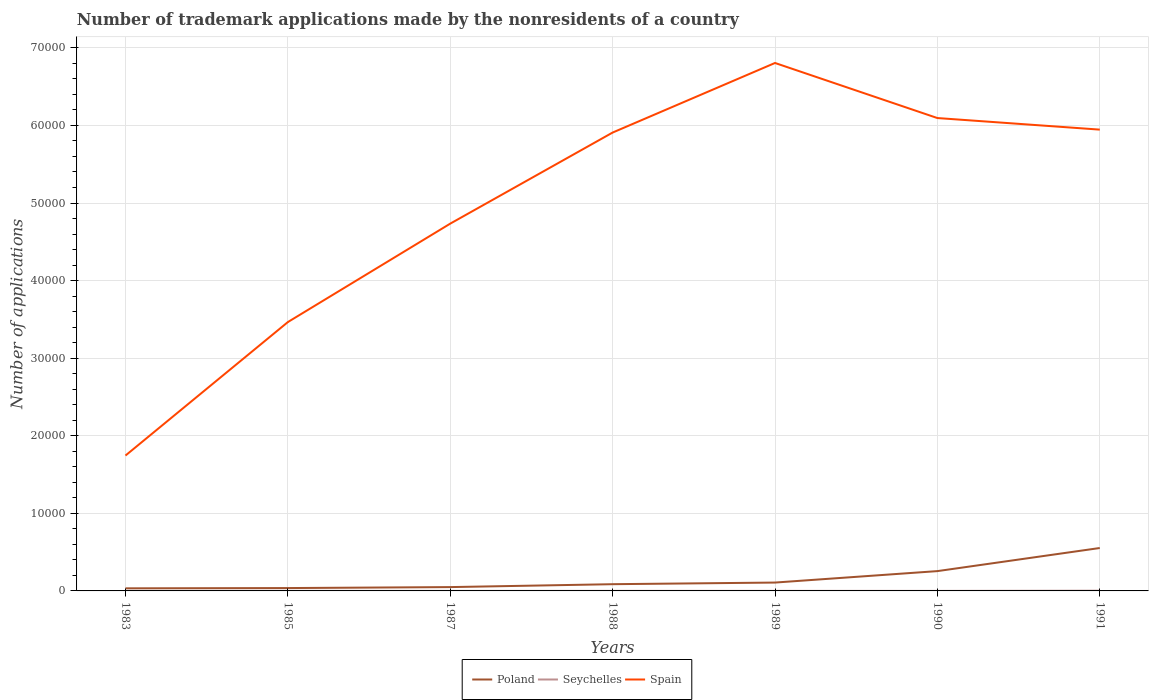How many different coloured lines are there?
Your answer should be compact. 3. In which year was the number of trademark applications made by the nonresidents in Poland maximum?
Provide a short and direct response. 1983. What is the difference between two consecutive major ticks on the Y-axis?
Your answer should be very brief. 10000. Where does the legend appear in the graph?
Make the answer very short. Bottom center. What is the title of the graph?
Ensure brevity in your answer.  Number of trademark applications made by the nonresidents of a country. Does "Somalia" appear as one of the legend labels in the graph?
Provide a succinct answer. No. What is the label or title of the X-axis?
Your answer should be very brief. Years. What is the label or title of the Y-axis?
Keep it short and to the point. Number of applications. What is the Number of applications in Poland in 1983?
Provide a succinct answer. 334. What is the Number of applications of Spain in 1983?
Provide a short and direct response. 1.74e+04. What is the Number of applications in Poland in 1985?
Offer a terse response. 369. What is the Number of applications in Spain in 1985?
Offer a terse response. 3.47e+04. What is the Number of applications of Poland in 1987?
Provide a short and direct response. 494. What is the Number of applications in Seychelles in 1987?
Give a very brief answer. 3. What is the Number of applications in Spain in 1987?
Keep it short and to the point. 4.73e+04. What is the Number of applications of Poland in 1988?
Provide a succinct answer. 867. What is the Number of applications of Spain in 1988?
Your answer should be very brief. 5.91e+04. What is the Number of applications of Poland in 1989?
Give a very brief answer. 1077. What is the Number of applications in Seychelles in 1989?
Offer a terse response. 7. What is the Number of applications of Spain in 1989?
Provide a short and direct response. 6.81e+04. What is the Number of applications of Poland in 1990?
Make the answer very short. 2554. What is the Number of applications of Seychelles in 1990?
Ensure brevity in your answer.  3. What is the Number of applications in Spain in 1990?
Your response must be concise. 6.10e+04. What is the Number of applications in Poland in 1991?
Your answer should be compact. 5531. What is the Number of applications in Seychelles in 1991?
Make the answer very short. 31. What is the Number of applications in Spain in 1991?
Ensure brevity in your answer.  5.95e+04. Across all years, what is the maximum Number of applications in Poland?
Your answer should be very brief. 5531. Across all years, what is the maximum Number of applications in Spain?
Give a very brief answer. 6.81e+04. Across all years, what is the minimum Number of applications in Poland?
Make the answer very short. 334. Across all years, what is the minimum Number of applications of Seychelles?
Your answer should be compact. 3. Across all years, what is the minimum Number of applications in Spain?
Keep it short and to the point. 1.74e+04. What is the total Number of applications of Poland in the graph?
Offer a terse response. 1.12e+04. What is the total Number of applications of Seychelles in the graph?
Provide a succinct answer. 67. What is the total Number of applications in Spain in the graph?
Provide a succinct answer. 3.47e+05. What is the difference between the Number of applications in Poland in 1983 and that in 1985?
Make the answer very short. -35. What is the difference between the Number of applications in Seychelles in 1983 and that in 1985?
Your response must be concise. -8. What is the difference between the Number of applications in Spain in 1983 and that in 1985?
Provide a succinct answer. -1.72e+04. What is the difference between the Number of applications of Poland in 1983 and that in 1987?
Your answer should be compact. -160. What is the difference between the Number of applications of Spain in 1983 and that in 1987?
Your answer should be very brief. -2.99e+04. What is the difference between the Number of applications of Poland in 1983 and that in 1988?
Offer a terse response. -533. What is the difference between the Number of applications of Spain in 1983 and that in 1988?
Provide a short and direct response. -4.16e+04. What is the difference between the Number of applications in Poland in 1983 and that in 1989?
Provide a succinct answer. -743. What is the difference between the Number of applications in Spain in 1983 and that in 1989?
Make the answer very short. -5.06e+04. What is the difference between the Number of applications of Poland in 1983 and that in 1990?
Offer a very short reply. -2220. What is the difference between the Number of applications of Seychelles in 1983 and that in 1990?
Your answer should be compact. 1. What is the difference between the Number of applications of Spain in 1983 and that in 1990?
Provide a short and direct response. -4.35e+04. What is the difference between the Number of applications in Poland in 1983 and that in 1991?
Your answer should be very brief. -5197. What is the difference between the Number of applications of Spain in 1983 and that in 1991?
Keep it short and to the point. -4.20e+04. What is the difference between the Number of applications of Poland in 1985 and that in 1987?
Provide a short and direct response. -125. What is the difference between the Number of applications of Spain in 1985 and that in 1987?
Your response must be concise. -1.27e+04. What is the difference between the Number of applications of Poland in 1985 and that in 1988?
Offer a terse response. -498. What is the difference between the Number of applications in Spain in 1985 and that in 1988?
Your response must be concise. -2.44e+04. What is the difference between the Number of applications of Poland in 1985 and that in 1989?
Give a very brief answer. -708. What is the difference between the Number of applications of Seychelles in 1985 and that in 1989?
Provide a short and direct response. 5. What is the difference between the Number of applications in Spain in 1985 and that in 1989?
Your answer should be compact. -3.34e+04. What is the difference between the Number of applications of Poland in 1985 and that in 1990?
Give a very brief answer. -2185. What is the difference between the Number of applications in Spain in 1985 and that in 1990?
Offer a very short reply. -2.63e+04. What is the difference between the Number of applications in Poland in 1985 and that in 1991?
Provide a short and direct response. -5162. What is the difference between the Number of applications in Seychelles in 1985 and that in 1991?
Keep it short and to the point. -19. What is the difference between the Number of applications of Spain in 1985 and that in 1991?
Offer a very short reply. -2.48e+04. What is the difference between the Number of applications in Poland in 1987 and that in 1988?
Give a very brief answer. -373. What is the difference between the Number of applications in Seychelles in 1987 and that in 1988?
Provide a short and direct response. -4. What is the difference between the Number of applications in Spain in 1987 and that in 1988?
Your answer should be very brief. -1.17e+04. What is the difference between the Number of applications of Poland in 1987 and that in 1989?
Make the answer very short. -583. What is the difference between the Number of applications of Seychelles in 1987 and that in 1989?
Give a very brief answer. -4. What is the difference between the Number of applications in Spain in 1987 and that in 1989?
Your answer should be compact. -2.07e+04. What is the difference between the Number of applications of Poland in 1987 and that in 1990?
Keep it short and to the point. -2060. What is the difference between the Number of applications of Seychelles in 1987 and that in 1990?
Make the answer very short. 0. What is the difference between the Number of applications in Spain in 1987 and that in 1990?
Provide a succinct answer. -1.36e+04. What is the difference between the Number of applications of Poland in 1987 and that in 1991?
Your answer should be compact. -5037. What is the difference between the Number of applications of Seychelles in 1987 and that in 1991?
Provide a short and direct response. -28. What is the difference between the Number of applications of Spain in 1987 and that in 1991?
Your response must be concise. -1.21e+04. What is the difference between the Number of applications in Poland in 1988 and that in 1989?
Keep it short and to the point. -210. What is the difference between the Number of applications of Seychelles in 1988 and that in 1989?
Keep it short and to the point. 0. What is the difference between the Number of applications in Spain in 1988 and that in 1989?
Give a very brief answer. -8969. What is the difference between the Number of applications in Poland in 1988 and that in 1990?
Offer a very short reply. -1687. What is the difference between the Number of applications in Seychelles in 1988 and that in 1990?
Your answer should be compact. 4. What is the difference between the Number of applications in Spain in 1988 and that in 1990?
Offer a very short reply. -1869. What is the difference between the Number of applications of Poland in 1988 and that in 1991?
Your answer should be very brief. -4664. What is the difference between the Number of applications of Seychelles in 1988 and that in 1991?
Provide a short and direct response. -24. What is the difference between the Number of applications in Spain in 1988 and that in 1991?
Your answer should be compact. -377. What is the difference between the Number of applications of Poland in 1989 and that in 1990?
Offer a very short reply. -1477. What is the difference between the Number of applications in Spain in 1989 and that in 1990?
Give a very brief answer. 7100. What is the difference between the Number of applications of Poland in 1989 and that in 1991?
Offer a very short reply. -4454. What is the difference between the Number of applications in Spain in 1989 and that in 1991?
Your answer should be very brief. 8592. What is the difference between the Number of applications of Poland in 1990 and that in 1991?
Offer a terse response. -2977. What is the difference between the Number of applications of Spain in 1990 and that in 1991?
Provide a short and direct response. 1492. What is the difference between the Number of applications of Poland in 1983 and the Number of applications of Seychelles in 1985?
Your answer should be compact. 322. What is the difference between the Number of applications of Poland in 1983 and the Number of applications of Spain in 1985?
Ensure brevity in your answer.  -3.43e+04. What is the difference between the Number of applications in Seychelles in 1983 and the Number of applications in Spain in 1985?
Your response must be concise. -3.47e+04. What is the difference between the Number of applications of Poland in 1983 and the Number of applications of Seychelles in 1987?
Your response must be concise. 331. What is the difference between the Number of applications of Poland in 1983 and the Number of applications of Spain in 1987?
Your answer should be very brief. -4.70e+04. What is the difference between the Number of applications of Seychelles in 1983 and the Number of applications of Spain in 1987?
Your answer should be compact. -4.73e+04. What is the difference between the Number of applications in Poland in 1983 and the Number of applications in Seychelles in 1988?
Provide a short and direct response. 327. What is the difference between the Number of applications of Poland in 1983 and the Number of applications of Spain in 1988?
Offer a very short reply. -5.88e+04. What is the difference between the Number of applications of Seychelles in 1983 and the Number of applications of Spain in 1988?
Your response must be concise. -5.91e+04. What is the difference between the Number of applications of Poland in 1983 and the Number of applications of Seychelles in 1989?
Provide a succinct answer. 327. What is the difference between the Number of applications of Poland in 1983 and the Number of applications of Spain in 1989?
Offer a terse response. -6.77e+04. What is the difference between the Number of applications in Seychelles in 1983 and the Number of applications in Spain in 1989?
Your answer should be compact. -6.80e+04. What is the difference between the Number of applications in Poland in 1983 and the Number of applications in Seychelles in 1990?
Give a very brief answer. 331. What is the difference between the Number of applications in Poland in 1983 and the Number of applications in Spain in 1990?
Give a very brief answer. -6.06e+04. What is the difference between the Number of applications in Seychelles in 1983 and the Number of applications in Spain in 1990?
Your answer should be compact. -6.10e+04. What is the difference between the Number of applications of Poland in 1983 and the Number of applications of Seychelles in 1991?
Offer a very short reply. 303. What is the difference between the Number of applications in Poland in 1983 and the Number of applications in Spain in 1991?
Provide a succinct answer. -5.91e+04. What is the difference between the Number of applications in Seychelles in 1983 and the Number of applications in Spain in 1991?
Give a very brief answer. -5.95e+04. What is the difference between the Number of applications in Poland in 1985 and the Number of applications in Seychelles in 1987?
Offer a terse response. 366. What is the difference between the Number of applications of Poland in 1985 and the Number of applications of Spain in 1987?
Provide a succinct answer. -4.70e+04. What is the difference between the Number of applications in Seychelles in 1985 and the Number of applications in Spain in 1987?
Your answer should be very brief. -4.73e+04. What is the difference between the Number of applications in Poland in 1985 and the Number of applications in Seychelles in 1988?
Your answer should be compact. 362. What is the difference between the Number of applications in Poland in 1985 and the Number of applications in Spain in 1988?
Make the answer very short. -5.87e+04. What is the difference between the Number of applications of Seychelles in 1985 and the Number of applications of Spain in 1988?
Make the answer very short. -5.91e+04. What is the difference between the Number of applications of Poland in 1985 and the Number of applications of Seychelles in 1989?
Provide a succinct answer. 362. What is the difference between the Number of applications in Poland in 1985 and the Number of applications in Spain in 1989?
Make the answer very short. -6.77e+04. What is the difference between the Number of applications of Seychelles in 1985 and the Number of applications of Spain in 1989?
Your answer should be very brief. -6.80e+04. What is the difference between the Number of applications of Poland in 1985 and the Number of applications of Seychelles in 1990?
Ensure brevity in your answer.  366. What is the difference between the Number of applications in Poland in 1985 and the Number of applications in Spain in 1990?
Provide a short and direct response. -6.06e+04. What is the difference between the Number of applications in Seychelles in 1985 and the Number of applications in Spain in 1990?
Offer a very short reply. -6.09e+04. What is the difference between the Number of applications in Poland in 1985 and the Number of applications in Seychelles in 1991?
Keep it short and to the point. 338. What is the difference between the Number of applications in Poland in 1985 and the Number of applications in Spain in 1991?
Ensure brevity in your answer.  -5.91e+04. What is the difference between the Number of applications in Seychelles in 1985 and the Number of applications in Spain in 1991?
Your response must be concise. -5.94e+04. What is the difference between the Number of applications in Poland in 1987 and the Number of applications in Seychelles in 1988?
Provide a succinct answer. 487. What is the difference between the Number of applications of Poland in 1987 and the Number of applications of Spain in 1988?
Provide a short and direct response. -5.86e+04. What is the difference between the Number of applications of Seychelles in 1987 and the Number of applications of Spain in 1988?
Your answer should be compact. -5.91e+04. What is the difference between the Number of applications of Poland in 1987 and the Number of applications of Seychelles in 1989?
Your answer should be compact. 487. What is the difference between the Number of applications in Poland in 1987 and the Number of applications in Spain in 1989?
Provide a short and direct response. -6.76e+04. What is the difference between the Number of applications of Seychelles in 1987 and the Number of applications of Spain in 1989?
Provide a short and direct response. -6.81e+04. What is the difference between the Number of applications in Poland in 1987 and the Number of applications in Seychelles in 1990?
Give a very brief answer. 491. What is the difference between the Number of applications in Poland in 1987 and the Number of applications in Spain in 1990?
Offer a very short reply. -6.05e+04. What is the difference between the Number of applications in Seychelles in 1987 and the Number of applications in Spain in 1990?
Provide a succinct answer. -6.10e+04. What is the difference between the Number of applications in Poland in 1987 and the Number of applications in Seychelles in 1991?
Offer a terse response. 463. What is the difference between the Number of applications of Poland in 1987 and the Number of applications of Spain in 1991?
Offer a very short reply. -5.90e+04. What is the difference between the Number of applications in Seychelles in 1987 and the Number of applications in Spain in 1991?
Your response must be concise. -5.95e+04. What is the difference between the Number of applications in Poland in 1988 and the Number of applications in Seychelles in 1989?
Offer a terse response. 860. What is the difference between the Number of applications in Poland in 1988 and the Number of applications in Spain in 1989?
Give a very brief answer. -6.72e+04. What is the difference between the Number of applications in Seychelles in 1988 and the Number of applications in Spain in 1989?
Keep it short and to the point. -6.80e+04. What is the difference between the Number of applications in Poland in 1988 and the Number of applications in Seychelles in 1990?
Make the answer very short. 864. What is the difference between the Number of applications in Poland in 1988 and the Number of applications in Spain in 1990?
Your answer should be very brief. -6.01e+04. What is the difference between the Number of applications in Seychelles in 1988 and the Number of applications in Spain in 1990?
Your answer should be compact. -6.09e+04. What is the difference between the Number of applications of Poland in 1988 and the Number of applications of Seychelles in 1991?
Your answer should be very brief. 836. What is the difference between the Number of applications of Poland in 1988 and the Number of applications of Spain in 1991?
Provide a succinct answer. -5.86e+04. What is the difference between the Number of applications in Seychelles in 1988 and the Number of applications in Spain in 1991?
Keep it short and to the point. -5.95e+04. What is the difference between the Number of applications in Poland in 1989 and the Number of applications in Seychelles in 1990?
Offer a terse response. 1074. What is the difference between the Number of applications in Poland in 1989 and the Number of applications in Spain in 1990?
Ensure brevity in your answer.  -5.99e+04. What is the difference between the Number of applications in Seychelles in 1989 and the Number of applications in Spain in 1990?
Make the answer very short. -6.09e+04. What is the difference between the Number of applications in Poland in 1989 and the Number of applications in Seychelles in 1991?
Offer a very short reply. 1046. What is the difference between the Number of applications of Poland in 1989 and the Number of applications of Spain in 1991?
Ensure brevity in your answer.  -5.84e+04. What is the difference between the Number of applications in Seychelles in 1989 and the Number of applications in Spain in 1991?
Provide a short and direct response. -5.95e+04. What is the difference between the Number of applications of Poland in 1990 and the Number of applications of Seychelles in 1991?
Offer a terse response. 2523. What is the difference between the Number of applications of Poland in 1990 and the Number of applications of Spain in 1991?
Provide a short and direct response. -5.69e+04. What is the difference between the Number of applications of Seychelles in 1990 and the Number of applications of Spain in 1991?
Ensure brevity in your answer.  -5.95e+04. What is the average Number of applications in Poland per year?
Your answer should be compact. 1603.71. What is the average Number of applications in Seychelles per year?
Provide a succinct answer. 9.57. What is the average Number of applications in Spain per year?
Make the answer very short. 4.96e+04. In the year 1983, what is the difference between the Number of applications of Poland and Number of applications of Seychelles?
Your answer should be very brief. 330. In the year 1983, what is the difference between the Number of applications of Poland and Number of applications of Spain?
Make the answer very short. -1.71e+04. In the year 1983, what is the difference between the Number of applications of Seychelles and Number of applications of Spain?
Your answer should be compact. -1.74e+04. In the year 1985, what is the difference between the Number of applications in Poland and Number of applications in Seychelles?
Your response must be concise. 357. In the year 1985, what is the difference between the Number of applications of Poland and Number of applications of Spain?
Offer a terse response. -3.43e+04. In the year 1985, what is the difference between the Number of applications in Seychelles and Number of applications in Spain?
Provide a succinct answer. -3.46e+04. In the year 1987, what is the difference between the Number of applications in Poland and Number of applications in Seychelles?
Your answer should be compact. 491. In the year 1987, what is the difference between the Number of applications of Poland and Number of applications of Spain?
Your answer should be very brief. -4.68e+04. In the year 1987, what is the difference between the Number of applications of Seychelles and Number of applications of Spain?
Your answer should be very brief. -4.73e+04. In the year 1988, what is the difference between the Number of applications in Poland and Number of applications in Seychelles?
Make the answer very short. 860. In the year 1988, what is the difference between the Number of applications of Poland and Number of applications of Spain?
Keep it short and to the point. -5.82e+04. In the year 1988, what is the difference between the Number of applications in Seychelles and Number of applications in Spain?
Provide a short and direct response. -5.91e+04. In the year 1989, what is the difference between the Number of applications of Poland and Number of applications of Seychelles?
Make the answer very short. 1070. In the year 1989, what is the difference between the Number of applications of Poland and Number of applications of Spain?
Your answer should be compact. -6.70e+04. In the year 1989, what is the difference between the Number of applications of Seychelles and Number of applications of Spain?
Your answer should be compact. -6.80e+04. In the year 1990, what is the difference between the Number of applications in Poland and Number of applications in Seychelles?
Offer a terse response. 2551. In the year 1990, what is the difference between the Number of applications of Poland and Number of applications of Spain?
Give a very brief answer. -5.84e+04. In the year 1990, what is the difference between the Number of applications of Seychelles and Number of applications of Spain?
Make the answer very short. -6.10e+04. In the year 1991, what is the difference between the Number of applications of Poland and Number of applications of Seychelles?
Provide a succinct answer. 5500. In the year 1991, what is the difference between the Number of applications of Poland and Number of applications of Spain?
Offer a terse response. -5.39e+04. In the year 1991, what is the difference between the Number of applications in Seychelles and Number of applications in Spain?
Your answer should be very brief. -5.94e+04. What is the ratio of the Number of applications in Poland in 1983 to that in 1985?
Your response must be concise. 0.91. What is the ratio of the Number of applications in Spain in 1983 to that in 1985?
Offer a very short reply. 0.5. What is the ratio of the Number of applications of Poland in 1983 to that in 1987?
Give a very brief answer. 0.68. What is the ratio of the Number of applications in Seychelles in 1983 to that in 1987?
Your response must be concise. 1.33. What is the ratio of the Number of applications in Spain in 1983 to that in 1987?
Ensure brevity in your answer.  0.37. What is the ratio of the Number of applications in Poland in 1983 to that in 1988?
Ensure brevity in your answer.  0.39. What is the ratio of the Number of applications of Spain in 1983 to that in 1988?
Give a very brief answer. 0.3. What is the ratio of the Number of applications of Poland in 1983 to that in 1989?
Your response must be concise. 0.31. What is the ratio of the Number of applications of Seychelles in 1983 to that in 1989?
Make the answer very short. 0.57. What is the ratio of the Number of applications of Spain in 1983 to that in 1989?
Offer a very short reply. 0.26. What is the ratio of the Number of applications of Poland in 1983 to that in 1990?
Your answer should be compact. 0.13. What is the ratio of the Number of applications in Seychelles in 1983 to that in 1990?
Ensure brevity in your answer.  1.33. What is the ratio of the Number of applications in Spain in 1983 to that in 1990?
Your answer should be compact. 0.29. What is the ratio of the Number of applications in Poland in 1983 to that in 1991?
Ensure brevity in your answer.  0.06. What is the ratio of the Number of applications in Seychelles in 1983 to that in 1991?
Your answer should be very brief. 0.13. What is the ratio of the Number of applications of Spain in 1983 to that in 1991?
Your response must be concise. 0.29. What is the ratio of the Number of applications in Poland in 1985 to that in 1987?
Your response must be concise. 0.75. What is the ratio of the Number of applications of Seychelles in 1985 to that in 1987?
Offer a very short reply. 4. What is the ratio of the Number of applications of Spain in 1985 to that in 1987?
Your response must be concise. 0.73. What is the ratio of the Number of applications of Poland in 1985 to that in 1988?
Provide a succinct answer. 0.43. What is the ratio of the Number of applications in Seychelles in 1985 to that in 1988?
Offer a very short reply. 1.71. What is the ratio of the Number of applications of Spain in 1985 to that in 1988?
Offer a terse response. 0.59. What is the ratio of the Number of applications in Poland in 1985 to that in 1989?
Your answer should be very brief. 0.34. What is the ratio of the Number of applications in Seychelles in 1985 to that in 1989?
Provide a succinct answer. 1.71. What is the ratio of the Number of applications of Spain in 1985 to that in 1989?
Offer a terse response. 0.51. What is the ratio of the Number of applications in Poland in 1985 to that in 1990?
Provide a succinct answer. 0.14. What is the ratio of the Number of applications in Spain in 1985 to that in 1990?
Keep it short and to the point. 0.57. What is the ratio of the Number of applications of Poland in 1985 to that in 1991?
Your answer should be very brief. 0.07. What is the ratio of the Number of applications of Seychelles in 1985 to that in 1991?
Offer a terse response. 0.39. What is the ratio of the Number of applications of Spain in 1985 to that in 1991?
Give a very brief answer. 0.58. What is the ratio of the Number of applications of Poland in 1987 to that in 1988?
Offer a very short reply. 0.57. What is the ratio of the Number of applications of Seychelles in 1987 to that in 1988?
Ensure brevity in your answer.  0.43. What is the ratio of the Number of applications in Spain in 1987 to that in 1988?
Keep it short and to the point. 0.8. What is the ratio of the Number of applications in Poland in 1987 to that in 1989?
Your answer should be compact. 0.46. What is the ratio of the Number of applications of Seychelles in 1987 to that in 1989?
Provide a succinct answer. 0.43. What is the ratio of the Number of applications of Spain in 1987 to that in 1989?
Ensure brevity in your answer.  0.7. What is the ratio of the Number of applications of Poland in 1987 to that in 1990?
Keep it short and to the point. 0.19. What is the ratio of the Number of applications in Spain in 1987 to that in 1990?
Provide a succinct answer. 0.78. What is the ratio of the Number of applications of Poland in 1987 to that in 1991?
Provide a short and direct response. 0.09. What is the ratio of the Number of applications in Seychelles in 1987 to that in 1991?
Ensure brevity in your answer.  0.1. What is the ratio of the Number of applications in Spain in 1987 to that in 1991?
Your answer should be very brief. 0.8. What is the ratio of the Number of applications in Poland in 1988 to that in 1989?
Your answer should be very brief. 0.81. What is the ratio of the Number of applications of Seychelles in 1988 to that in 1989?
Give a very brief answer. 1. What is the ratio of the Number of applications of Spain in 1988 to that in 1989?
Keep it short and to the point. 0.87. What is the ratio of the Number of applications of Poland in 1988 to that in 1990?
Keep it short and to the point. 0.34. What is the ratio of the Number of applications of Seychelles in 1988 to that in 1990?
Make the answer very short. 2.33. What is the ratio of the Number of applications of Spain in 1988 to that in 1990?
Ensure brevity in your answer.  0.97. What is the ratio of the Number of applications of Poland in 1988 to that in 1991?
Offer a very short reply. 0.16. What is the ratio of the Number of applications in Seychelles in 1988 to that in 1991?
Offer a very short reply. 0.23. What is the ratio of the Number of applications in Spain in 1988 to that in 1991?
Your answer should be very brief. 0.99. What is the ratio of the Number of applications in Poland in 1989 to that in 1990?
Give a very brief answer. 0.42. What is the ratio of the Number of applications of Seychelles in 1989 to that in 1990?
Provide a succinct answer. 2.33. What is the ratio of the Number of applications in Spain in 1989 to that in 1990?
Provide a short and direct response. 1.12. What is the ratio of the Number of applications of Poland in 1989 to that in 1991?
Provide a succinct answer. 0.19. What is the ratio of the Number of applications in Seychelles in 1989 to that in 1991?
Offer a terse response. 0.23. What is the ratio of the Number of applications of Spain in 1989 to that in 1991?
Your answer should be compact. 1.14. What is the ratio of the Number of applications of Poland in 1990 to that in 1991?
Ensure brevity in your answer.  0.46. What is the ratio of the Number of applications in Seychelles in 1990 to that in 1991?
Provide a succinct answer. 0.1. What is the ratio of the Number of applications of Spain in 1990 to that in 1991?
Provide a short and direct response. 1.03. What is the difference between the highest and the second highest Number of applications in Poland?
Ensure brevity in your answer.  2977. What is the difference between the highest and the second highest Number of applications in Seychelles?
Keep it short and to the point. 19. What is the difference between the highest and the second highest Number of applications in Spain?
Your answer should be very brief. 7100. What is the difference between the highest and the lowest Number of applications in Poland?
Make the answer very short. 5197. What is the difference between the highest and the lowest Number of applications of Seychelles?
Offer a terse response. 28. What is the difference between the highest and the lowest Number of applications of Spain?
Provide a short and direct response. 5.06e+04. 